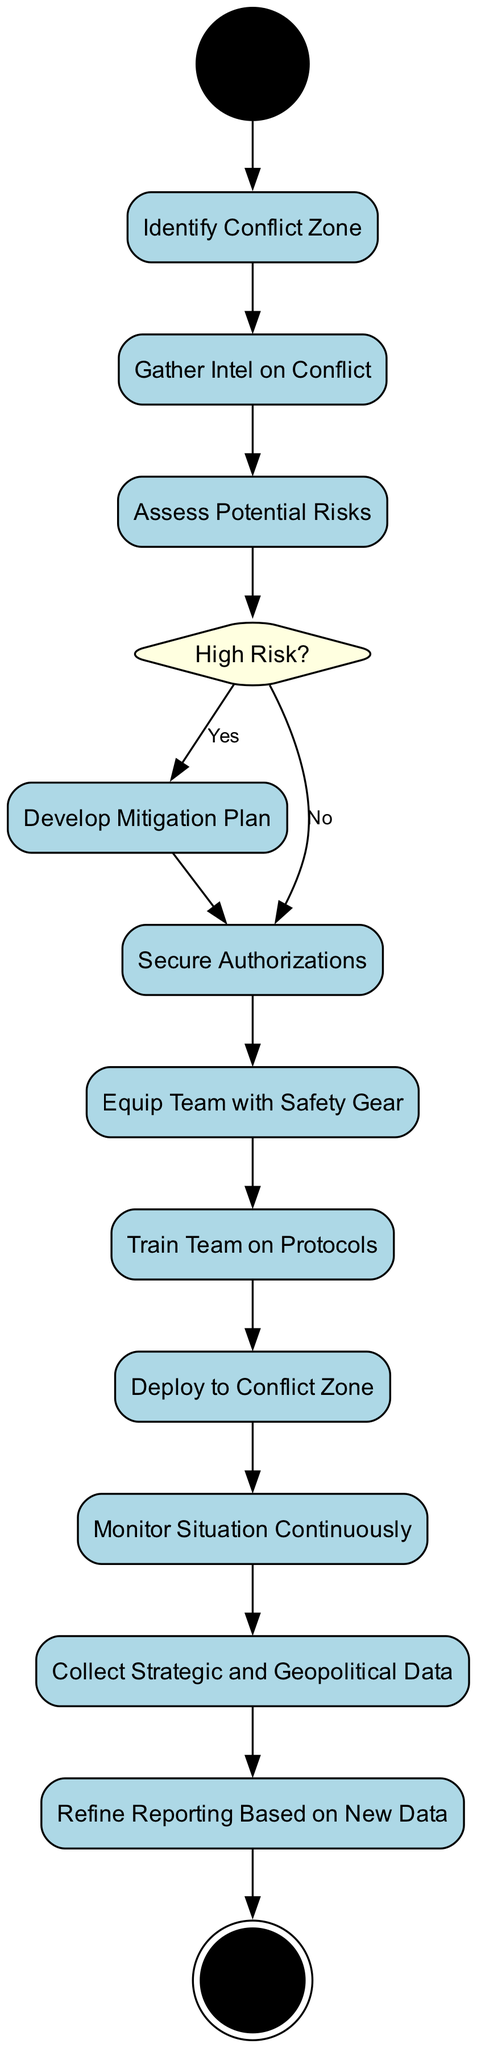What is the first activity in the process? The diagram begins at the "Start" node, and the first activity that follows is "Identify Conflict Zone."
Answer: Identify Conflict Zone How many decision nodes are present in the diagram? There is one decision node labeled "High Risk?" that assesses the risk level encountered in the process.
Answer: 1 Which activity follows after "Secure Authorizations"? After "Secure Authorizations," the next activity is "Equip Team with Safety Gear," indicating the sequence of actions taken.
Answer: Equip Team with Safety Gear What condition leads to the development of a mitigation plan? The condition that directs the process to "Develop Mitigation Plan" is when the assessment of risk is determined to be "Yes" at the "High Risk?" decision node.
Answer: Yes List the last two activities before reaching the end of the process. The last two activities before the end are "Collect Strategic and Geopolitical Data" followed by "Refine Reporting Based on New Data."
Answer: Collect Strategic and Geopolitical Data, Refine Reporting Based on New Data How is the flow of the diagram from "Assess Potential Risks" affected by the risk level? The flow diverges at the "High Risk?" decision node; if the answer is "Yes," it leads to "Develop Mitigation Plan," otherwise, it leads to "Secure Authorizations."
Answer: Two paths What is the activity preceding "Deploy to Conflict Zone"? The activity that comes just before "Deploy to Conflict Zone" is "Train Team on Protocols," highlighting the preparation steps before deployment.
Answer: Train Team on Protocols Which action involves incorporating feedback from ongoing situation monitoring? The action that incorporates feedback from ongoing monitoring is "Refine Reporting Based on New Data," emphasizing the adaptive nature of reporting in conflict zones.
Answer: Refine Reporting Based on New Data 